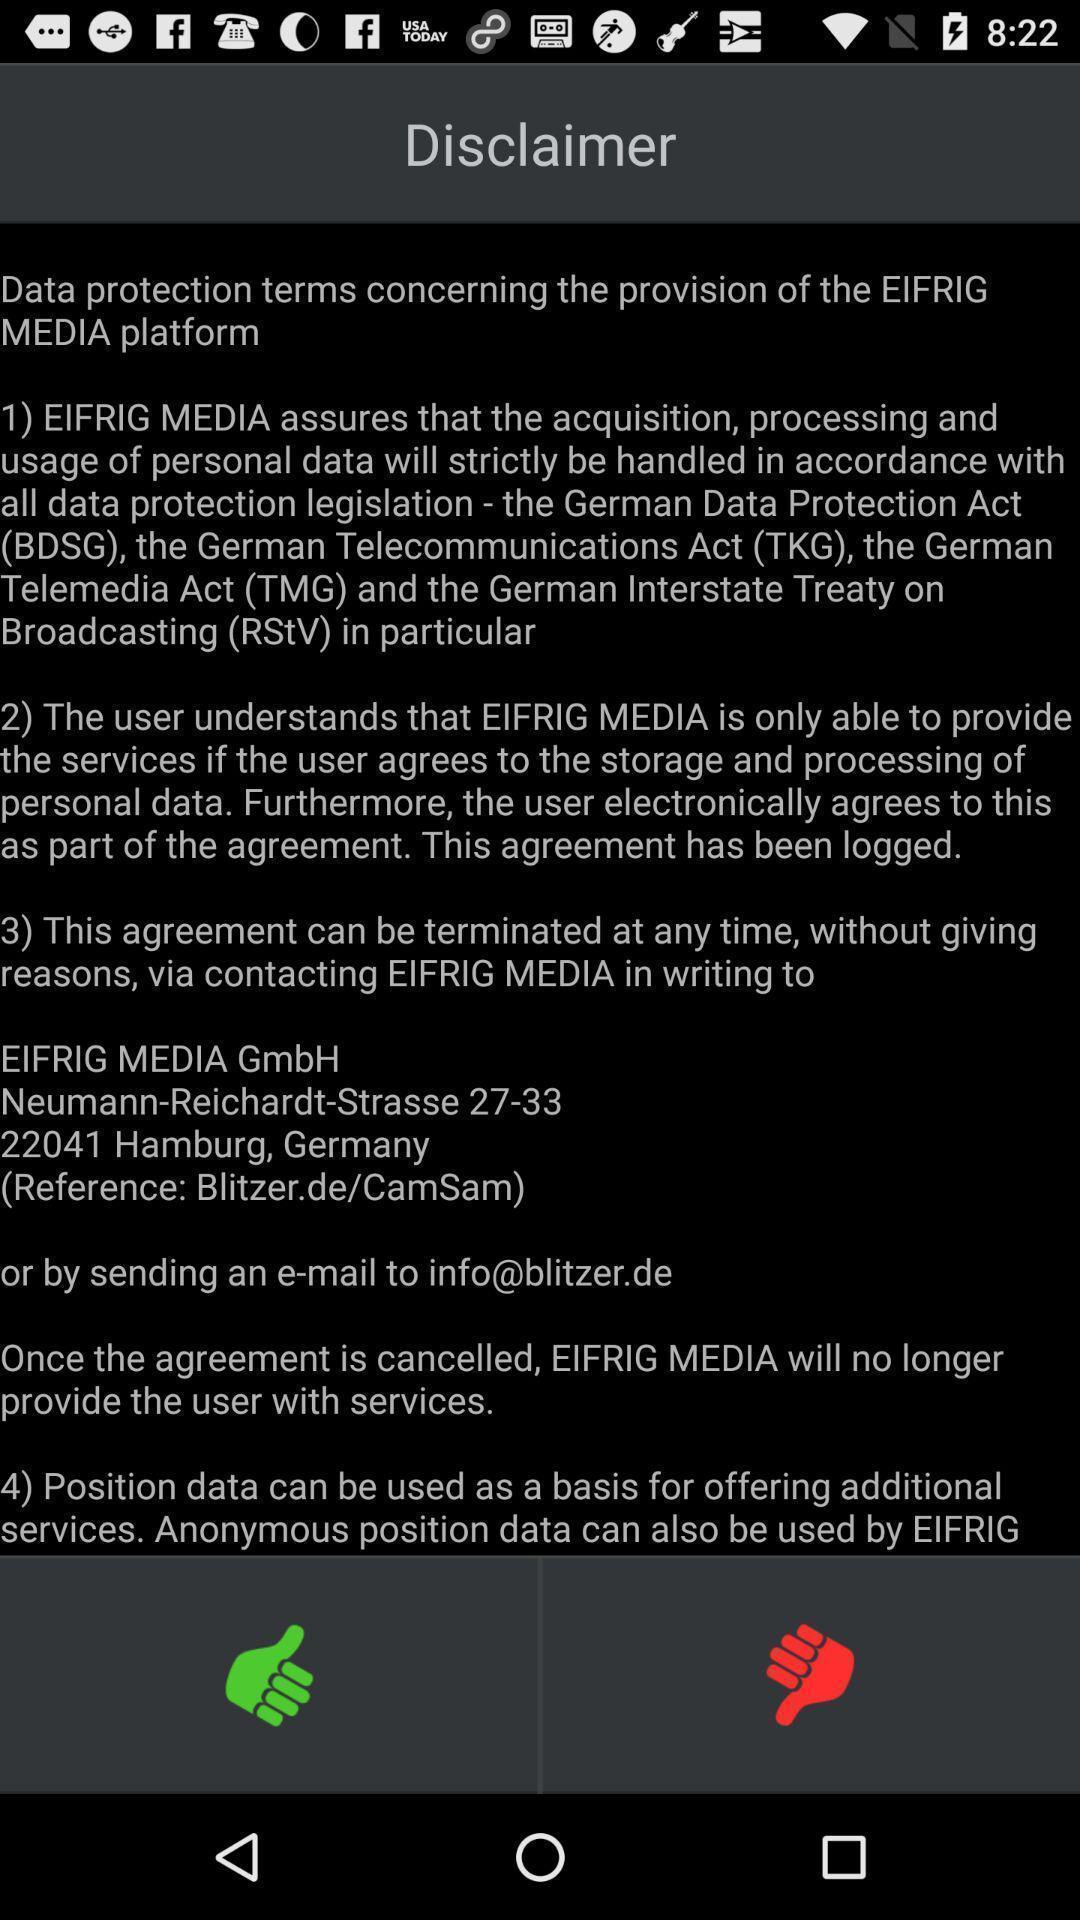Explain what's happening in this screen capture. Window displaying the alert message. 